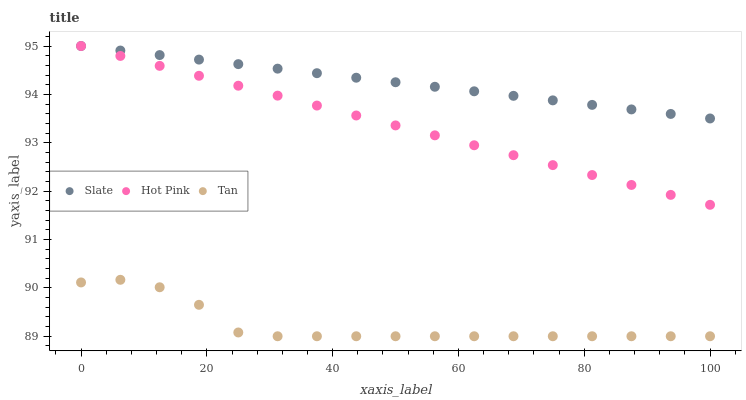Does Tan have the minimum area under the curve?
Answer yes or no. Yes. Does Slate have the maximum area under the curve?
Answer yes or no. Yes. Does Hot Pink have the minimum area under the curve?
Answer yes or no. No. Does Hot Pink have the maximum area under the curve?
Answer yes or no. No. Is Slate the smoothest?
Answer yes or no. Yes. Is Tan the roughest?
Answer yes or no. Yes. Is Hot Pink the smoothest?
Answer yes or no. No. Is Hot Pink the roughest?
Answer yes or no. No. Does Tan have the lowest value?
Answer yes or no. Yes. Does Hot Pink have the lowest value?
Answer yes or no. No. Does Hot Pink have the highest value?
Answer yes or no. Yes. Does Tan have the highest value?
Answer yes or no. No. Is Tan less than Hot Pink?
Answer yes or no. Yes. Is Slate greater than Tan?
Answer yes or no. Yes. Does Hot Pink intersect Slate?
Answer yes or no. Yes. Is Hot Pink less than Slate?
Answer yes or no. No. Is Hot Pink greater than Slate?
Answer yes or no. No. Does Tan intersect Hot Pink?
Answer yes or no. No. 